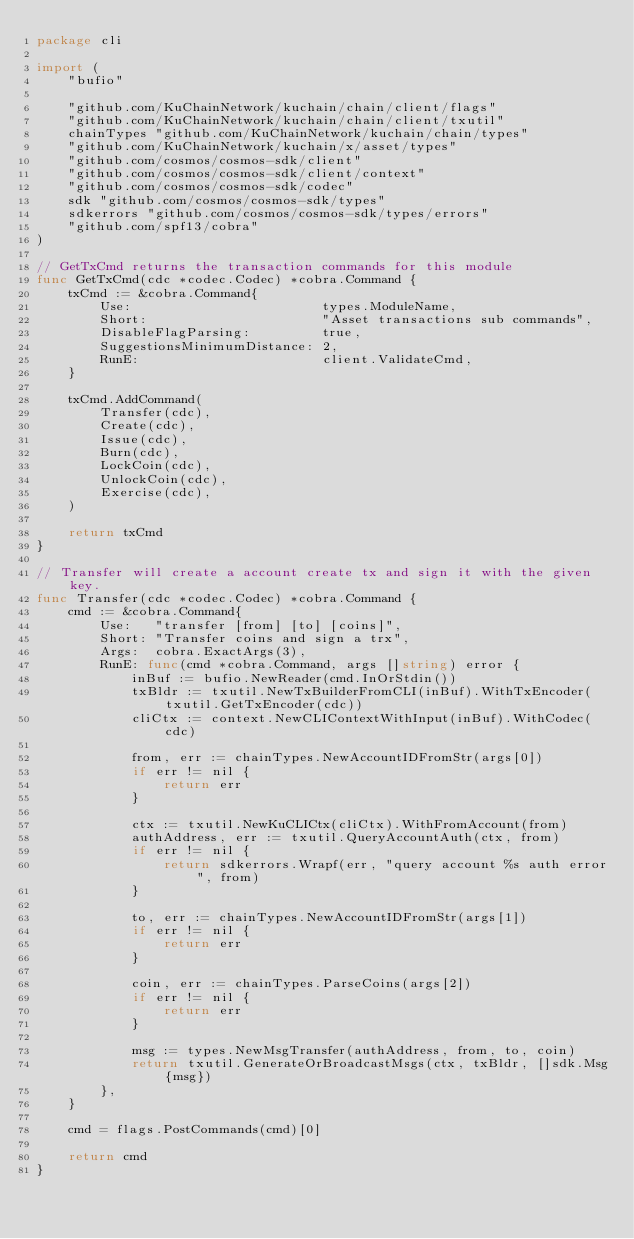Convert code to text. <code><loc_0><loc_0><loc_500><loc_500><_Go_>package cli

import (
	"bufio"

	"github.com/KuChainNetwork/kuchain/chain/client/flags"
	"github.com/KuChainNetwork/kuchain/chain/client/txutil"
	chainTypes "github.com/KuChainNetwork/kuchain/chain/types"
	"github.com/KuChainNetwork/kuchain/x/asset/types"
	"github.com/cosmos/cosmos-sdk/client"
	"github.com/cosmos/cosmos-sdk/client/context"
	"github.com/cosmos/cosmos-sdk/codec"
	sdk "github.com/cosmos/cosmos-sdk/types"
	sdkerrors "github.com/cosmos/cosmos-sdk/types/errors"
	"github.com/spf13/cobra"
)

// GetTxCmd returns the transaction commands for this module
func GetTxCmd(cdc *codec.Codec) *cobra.Command {
	txCmd := &cobra.Command{
		Use:                        types.ModuleName,
		Short:                      "Asset transactions sub commands",
		DisableFlagParsing:         true,
		SuggestionsMinimumDistance: 2,
		RunE:                       client.ValidateCmd,
	}

	txCmd.AddCommand(
		Transfer(cdc),
		Create(cdc),
		Issue(cdc),
		Burn(cdc),
		LockCoin(cdc),
		UnlockCoin(cdc),
		Exercise(cdc),
	)

	return txCmd
}

// Transfer will create a account create tx and sign it with the given key.
func Transfer(cdc *codec.Codec) *cobra.Command {
	cmd := &cobra.Command{
		Use:   "transfer [from] [to] [coins]",
		Short: "Transfer coins and sign a trx",
		Args:  cobra.ExactArgs(3),
		RunE: func(cmd *cobra.Command, args []string) error {
			inBuf := bufio.NewReader(cmd.InOrStdin())
			txBldr := txutil.NewTxBuilderFromCLI(inBuf).WithTxEncoder(txutil.GetTxEncoder(cdc))
			cliCtx := context.NewCLIContextWithInput(inBuf).WithCodec(cdc)

			from, err := chainTypes.NewAccountIDFromStr(args[0])
			if err != nil {
				return err
			}

			ctx := txutil.NewKuCLICtx(cliCtx).WithFromAccount(from)
			authAddress, err := txutil.QueryAccountAuth(ctx, from)
			if err != nil {
				return sdkerrors.Wrapf(err, "query account %s auth error", from)
			}

			to, err := chainTypes.NewAccountIDFromStr(args[1])
			if err != nil {
				return err
			}

			coin, err := chainTypes.ParseCoins(args[2])
			if err != nil {
				return err
			}

			msg := types.NewMsgTransfer(authAddress, from, to, coin)
			return txutil.GenerateOrBroadcastMsgs(ctx, txBldr, []sdk.Msg{msg})
		},
	}

	cmd = flags.PostCommands(cmd)[0]

	return cmd
}
</code> 